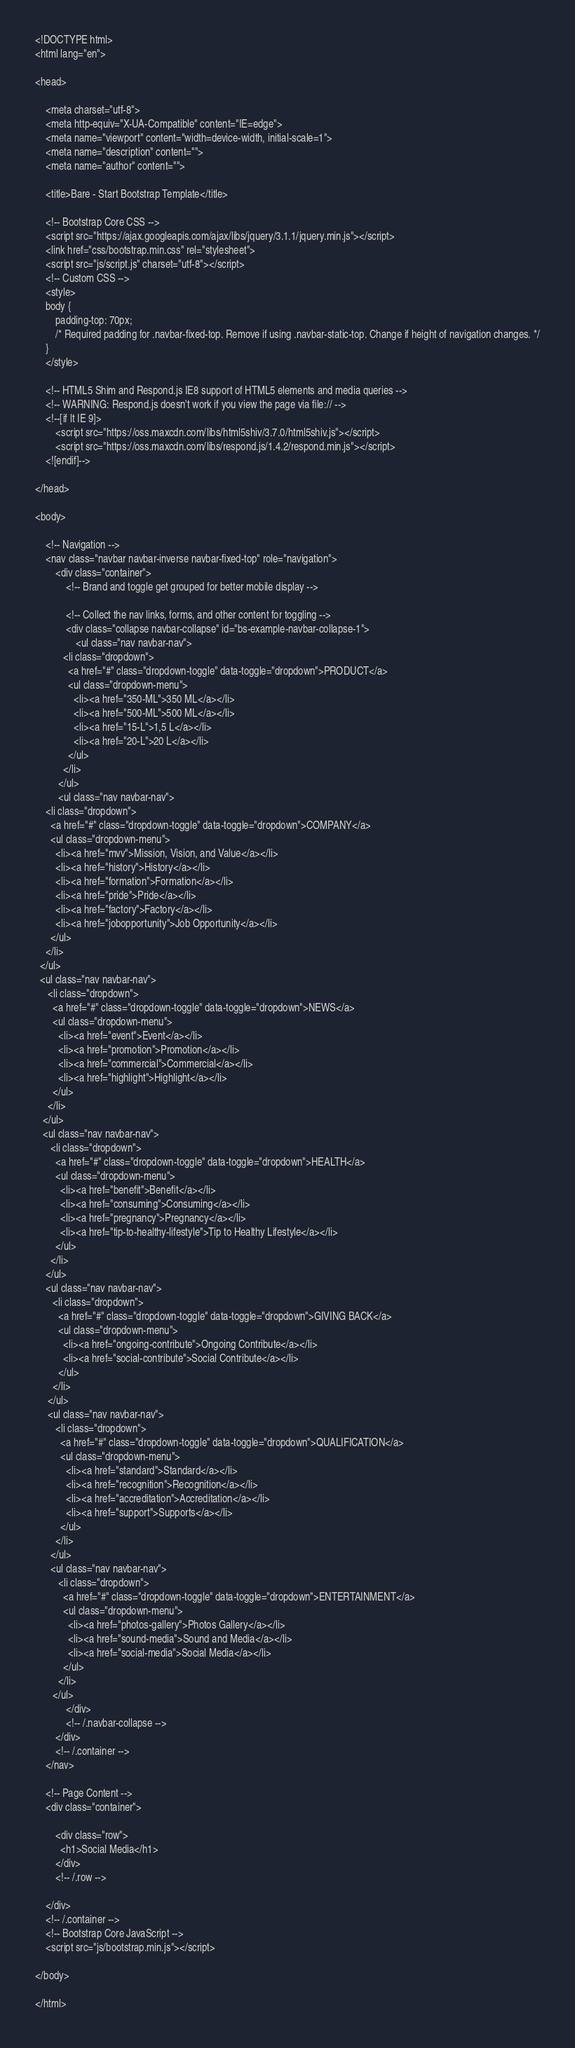<code> <loc_0><loc_0><loc_500><loc_500><_PHP_><!DOCTYPE html>
<html lang="en">

<head>

    <meta charset="utf-8">
    <meta http-equiv="X-UA-Compatible" content="IE=edge">
    <meta name="viewport" content="width=device-width, initial-scale=1">
    <meta name="description" content="">
    <meta name="author" content="">

    <title>Bare - Start Bootstrap Template</title>

    <!-- Bootstrap Core CSS -->
    <script src="https://ajax.googleapis.com/ajax/libs/jquery/3.1.1/jquery.min.js"></script>
    <link href="css/bootstrap.min.css" rel="stylesheet">
    <script src="js/script.js" charset="utf-8"></script>
    <!-- Custom CSS -->
    <style>
    body {
        padding-top: 70px;
        /* Required padding for .navbar-fixed-top. Remove if using .navbar-static-top. Change if height of navigation changes. */
    }
    </style>

    <!-- HTML5 Shim and Respond.js IE8 support of HTML5 elements and media queries -->
    <!-- WARNING: Respond.js doesn't work if you view the page via file:// -->
    <!--[if lt IE 9]>
        <script src="https://oss.maxcdn.com/libs/html5shiv/3.7.0/html5shiv.js"></script>
        <script src="https://oss.maxcdn.com/libs/respond.js/1.4.2/respond.min.js"></script>
    <![endif]-->

</head>

<body>

    <!-- Navigation -->
    <nav class="navbar navbar-inverse navbar-fixed-top" role="navigation">
        <div class="container">
            <!-- Brand and toggle get grouped for better mobile display -->

            <!-- Collect the nav links, forms, and other content for toggling -->
            <div class="collapse navbar-collapse" id="bs-example-navbar-collapse-1">
                <ul class="nav navbar-nav">
           <li class="dropdown">
             <a href="#" class="dropdown-toggle" data-toggle="dropdown">PRODUCT</a>
             <ul class="dropdown-menu">
               <li><a href="350-ML">350 ML</a></li>
               <li><a href="500-ML">500 ML</a></li>
               <li><a href="15-L">1,5 L</a></li>
               <li><a href="20-L">20 L</a></li>
             </ul>
           </li>
         </ul>
         <ul class="nav navbar-nav">
    <li class="dropdown">
      <a href="#" class="dropdown-toggle" data-toggle="dropdown">COMPANY</a>
      <ul class="dropdown-menu">
        <li><a href="mvv">Mission, Vision, and Value</a></li>
        <li><a href="history">History</a></li>
        <li><a href="formation">Formation</a></li>
        <li><a href="pride">Pride</a></li>
        <li><a href="factory">Factory</a></li>
        <li><a href="jobopportunity">Job Opportunity</a></li>
      </ul>
    </li>
  </ul>
  <ul class="nav navbar-nav">
     <li class="dropdown">
       <a href="#" class="dropdown-toggle" data-toggle="dropdown">NEWS</a>
       <ul class="dropdown-menu">
         <li><a href="event">Event</a></li>
         <li><a href="promotion">Promotion</a></li>
         <li><a href="commercial">Commercial</a></li>
         <li><a href="highlight">Highlight</a></li>
       </ul>
     </li>
   </ul>
   <ul class="nav navbar-nav">
      <li class="dropdown">
        <a href="#" class="dropdown-toggle" data-toggle="dropdown">HEALTH</a>
        <ul class="dropdown-menu">
          <li><a href="benefit">Benefit</a></li>
          <li><a href="consuming">Consuming</a></li>
          <li><a href="pregnancy">Pregnancy</a></li>
          <li><a href="tip-to-healthy-lifestyle">Tip to Healthy Lifestyle</a></li>
        </ul>
      </li>
    </ul>
    <ul class="nav navbar-nav">
       <li class="dropdown">
         <a href="#" class="dropdown-toggle" data-toggle="dropdown">GIVING BACK</a>
         <ul class="dropdown-menu">
           <li><a href="ongoing-contribute">Ongoing Contribute</a></li>
           <li><a href="social-contribute">Social Contribute</a></li>
         </ul>
       </li>
     </ul>
     <ul class="nav navbar-nav">
        <li class="dropdown">
          <a href="#" class="dropdown-toggle" data-toggle="dropdown">QUALIFICATION</a>
          <ul class="dropdown-menu">
            <li><a href="standard">Standard</a></li>
            <li><a href="recognition">Recognition</a></li>
            <li><a href="accreditation">Accreditation</a></li>
            <li><a href="support">Supports</a></li>
          </ul>
        </li>
      </ul>
      <ul class="nav navbar-nav">
         <li class="dropdown">
           <a href="#" class="dropdown-toggle" data-toggle="dropdown">ENTERTAINMENT</a>
           <ul class="dropdown-menu">
             <li><a href="photos-gallery">Photos Gallery</a></li>
             <li><a href="sound-media">Sound and Media</a></li>
             <li><a href="social-media">Social Media</a></li>
           </ul>
         </li>
       </ul>
            </div>
            <!-- /.navbar-collapse -->
        </div>
        <!-- /.container -->
    </nav>

    <!-- Page Content -->
    <div class="container">

        <div class="row">
          <h1>Social Media</h1>
        </div>
        <!-- /.row -->

    </div>
    <!-- /.container -->
    <!-- Bootstrap Core JavaScript -->
    <script src="js/bootstrap.min.js"></script>

</body>

</html>
</code> 